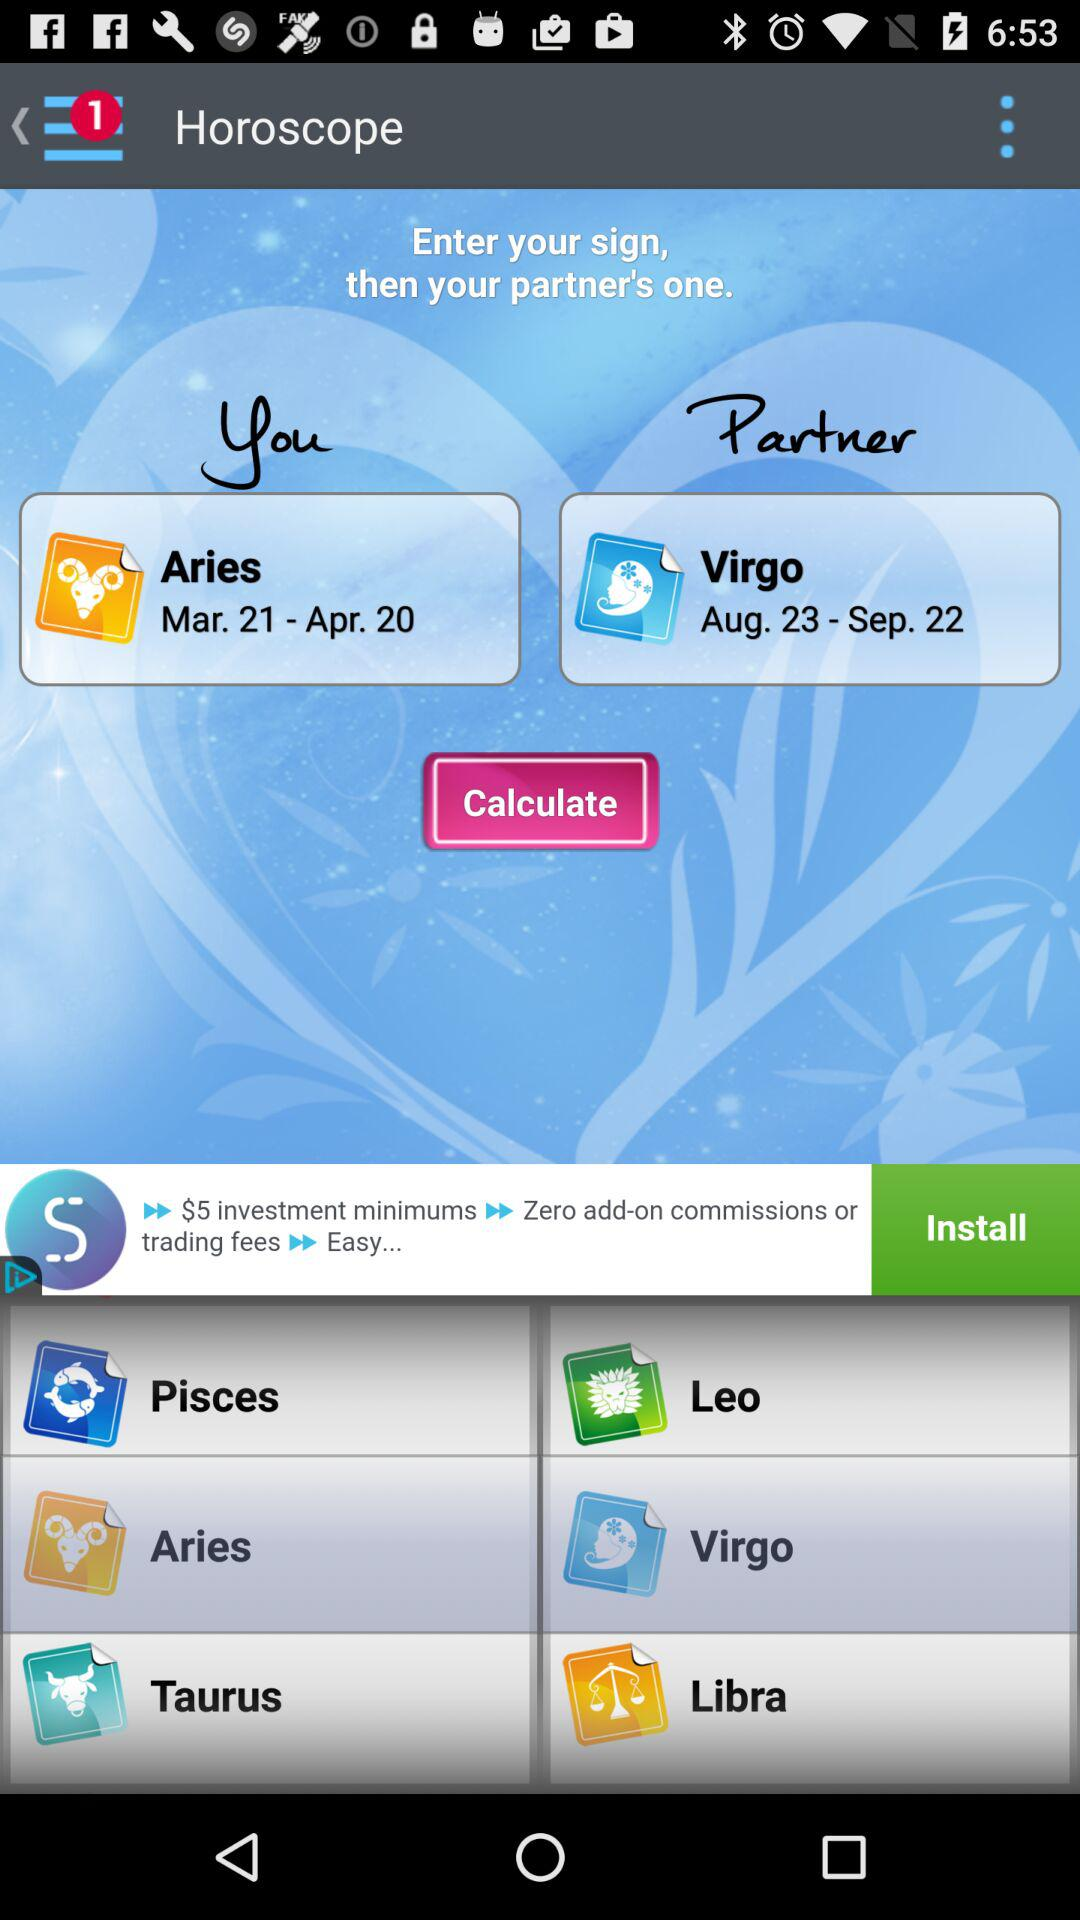What is my partner's zodiac sign? Your partner's zodiac sign is Virgo. 